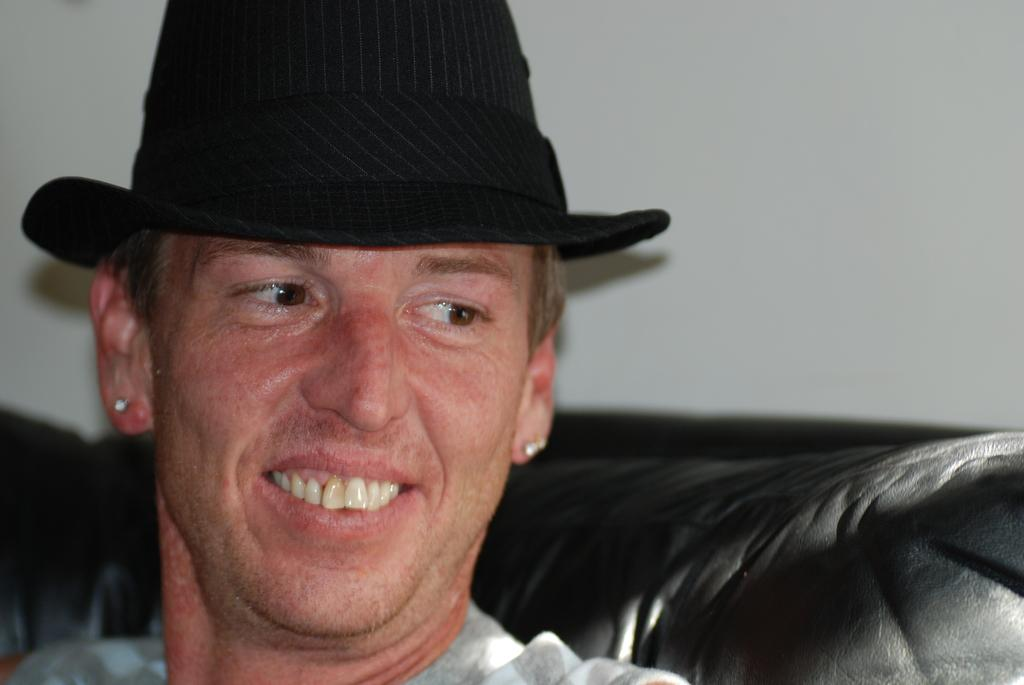Who is present in the image? There is a man in the image. What is the man wearing on his head? The man is wearing a hat. What is the man sitting on in the image? The man is sitting in a sofa. What can be seen behind the man in the image? There is a wall visible in the image. How many children are sitting with the man in the image? There are no children present in the image; only the man is visible. 